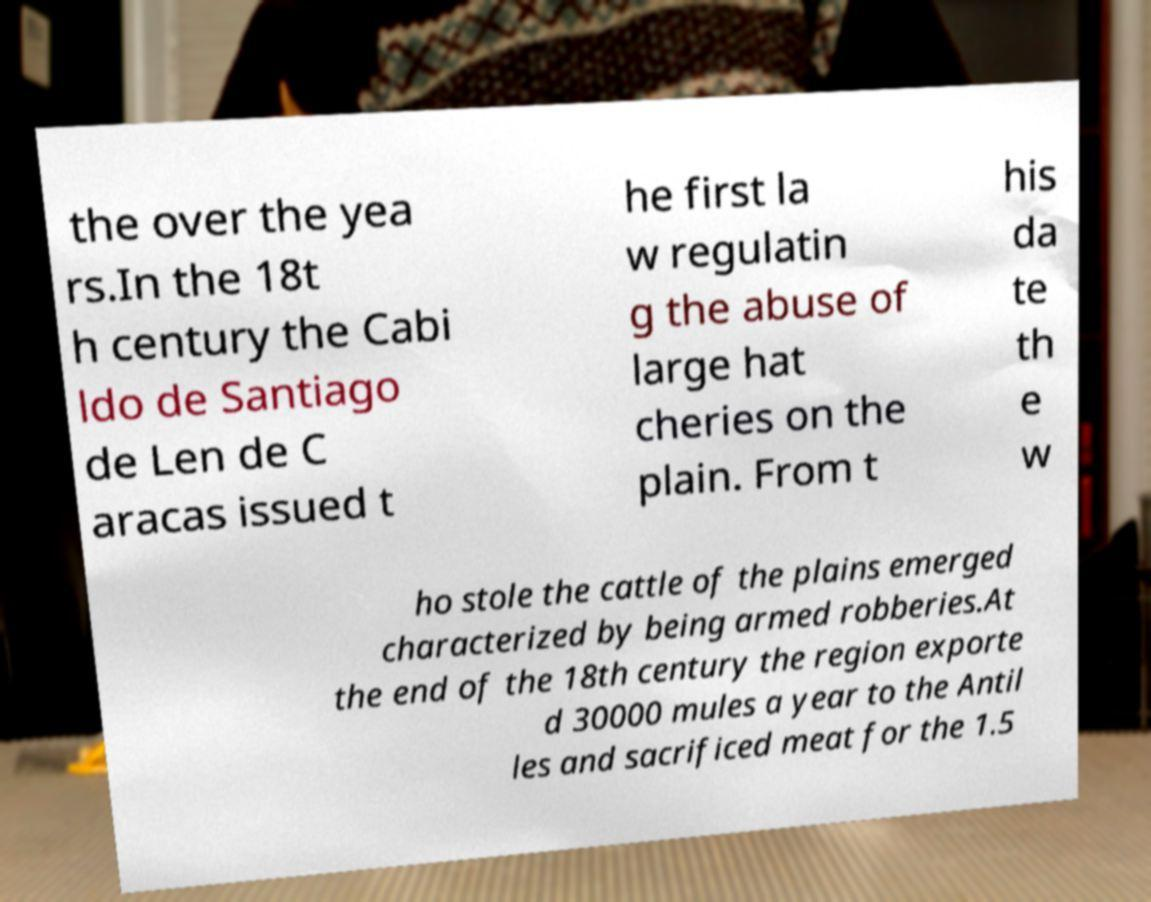Please read and relay the text visible in this image. What does it say? the over the yea rs.In the 18t h century the Cabi ldo de Santiago de Len de C aracas issued t he first la w regulatin g the abuse of large hat cheries on the plain. From t his da te th e w ho stole the cattle of the plains emerged characterized by being armed robberies.At the end of the 18th century the region exporte d 30000 mules a year to the Antil les and sacrificed meat for the 1.5 